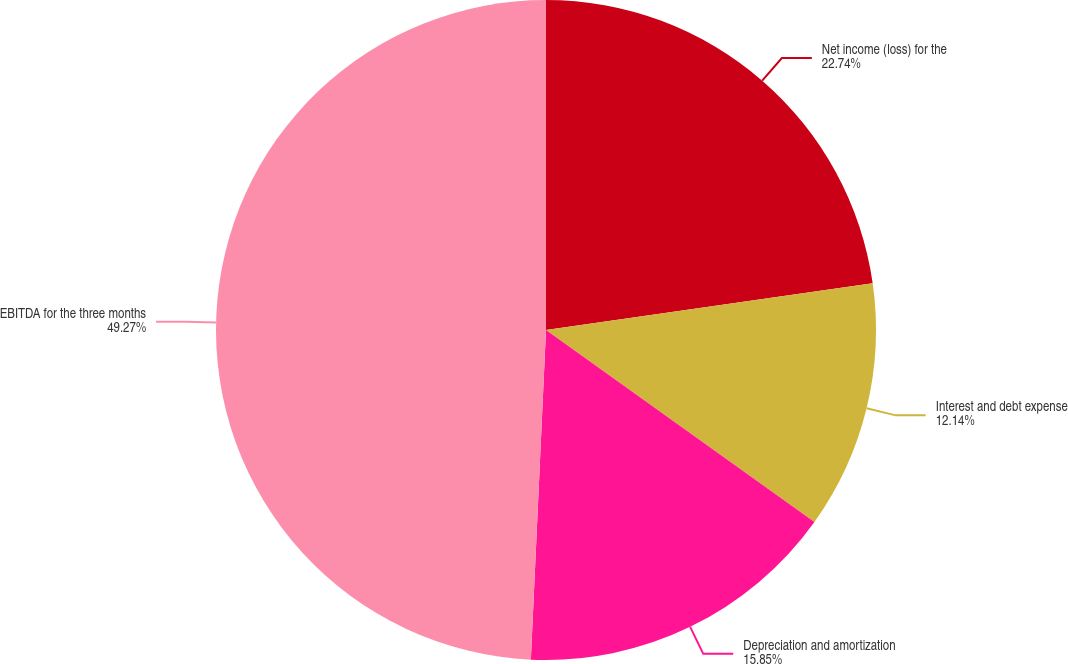<chart> <loc_0><loc_0><loc_500><loc_500><pie_chart><fcel>Net income (loss) for the<fcel>Interest and debt expense<fcel>Depreciation and amortization<fcel>EBITDA for the three months<nl><fcel>22.74%<fcel>12.14%<fcel>15.85%<fcel>49.27%<nl></chart> 